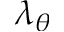<formula> <loc_0><loc_0><loc_500><loc_500>\lambda _ { \theta }</formula> 